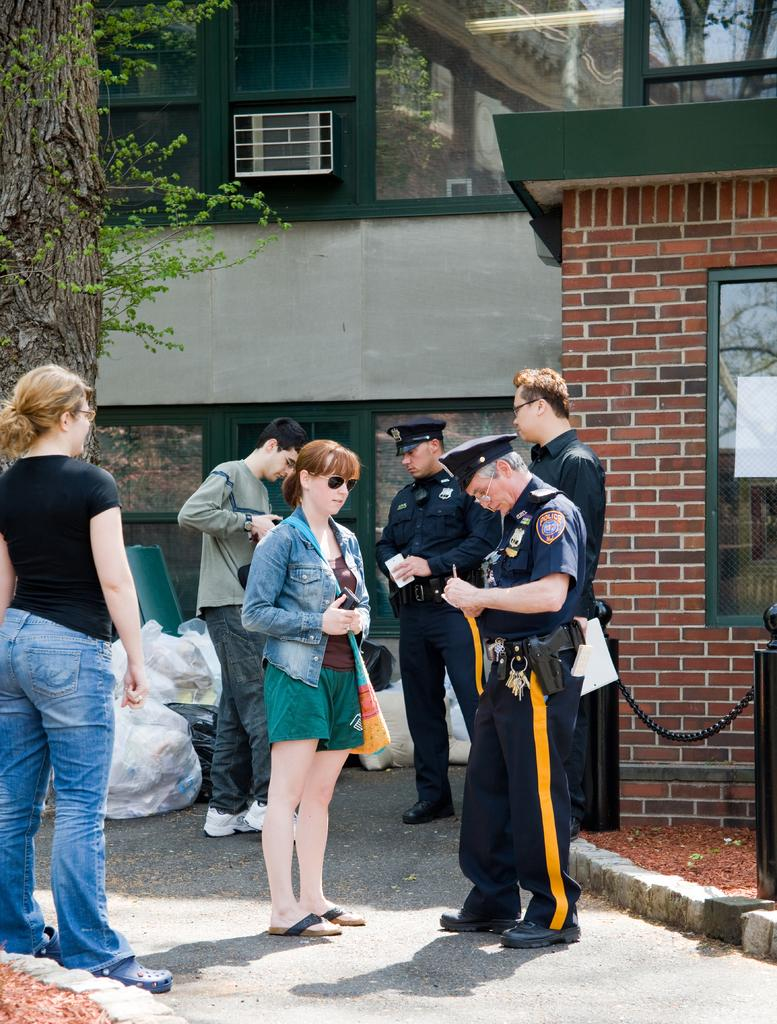Who are the people in the foreground of the image? The people in the foreground of the image are cops. What can be seen in the foreground of the image besides the cops? There is garbage (polythene) in the foreground of the image. What is visible in the background of the image? There are buildings and a tree in the background of the image. What type of lace can be seen on the tree in the image? There is no lace present on the tree in the image. What channel is the image from? The image is not from a specific channel; it is a still image. 